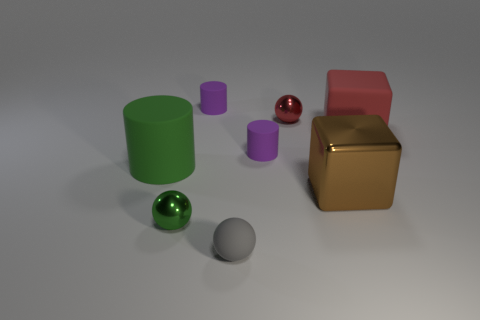Can you describe the lighting in this scene? The lighting in the scene appears diffuse and soft, creating gentle shadows beneath the objects. It seems to come from above, as indicated by the shadow placement, which contributes to the calm and balanced atmosphere of the composition. 